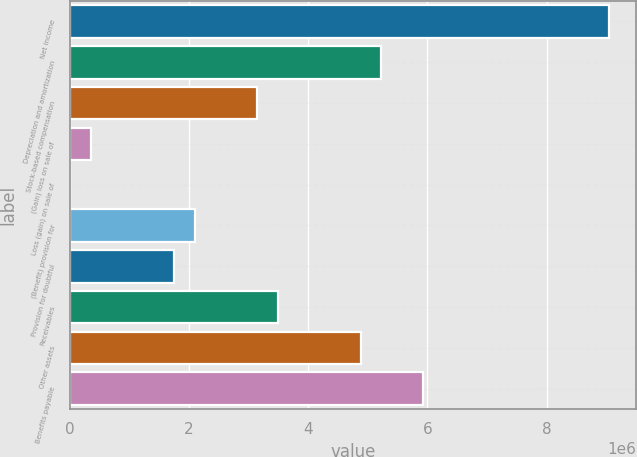<chart> <loc_0><loc_0><loc_500><loc_500><bar_chart><fcel>Net income<fcel>Depreciation and amortization<fcel>Stock-based compensation<fcel>(Gain) loss on sale of<fcel>Loss (gain) on sale of<fcel>(Benefit) provision for<fcel>Provision for doubtful<fcel>Receivables<fcel>Other assets<fcel>Benefits payable<nl><fcel>9.05177e+06<fcel>5.22711e+06<fcel>3.14093e+06<fcel>359364<fcel>11668<fcel>2.09785e+06<fcel>1.75015e+06<fcel>3.48863e+06<fcel>4.87942e+06<fcel>5.92251e+06<nl></chart> 